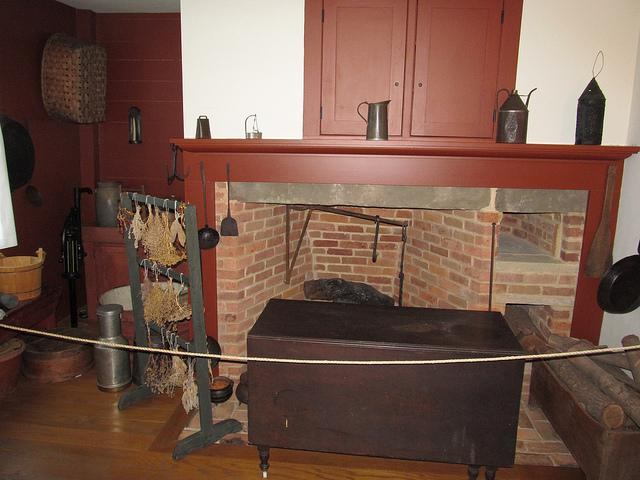Why is the area in the room roped off?

Choices:
A) historical significance
B) wet paint
C) construction
D) crime scene historical significance 